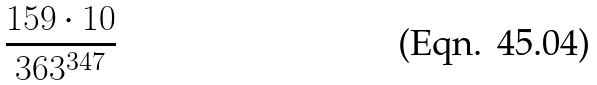<formula> <loc_0><loc_0><loc_500><loc_500>\frac { 1 5 9 \cdot 1 0 } { 3 6 3 ^ { 3 4 7 } }</formula> 